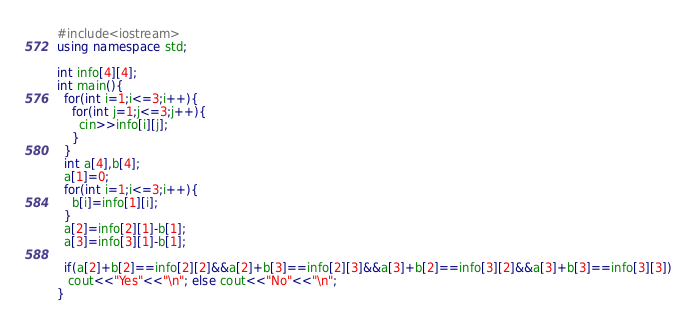<code> <loc_0><loc_0><loc_500><loc_500><_C++_>#include<iostream>
using namespace std;

int info[4][4];
int main(){
  for(int i=1;i<=3;i++){
    for(int j=1;j<=3;j++){
      cin>>info[i][j];
    }
  }
  int a[4],b[4];
  a[1]=0;
  for(int i=1;i<=3;i++){
    b[i]=info[1][i];
  }
  a[2]=info[2][1]-b[1];
  a[3]=info[3][1]-b[1];

  if(a[2]+b[2]==info[2][2]&&a[2]+b[3]==info[2][3]&&a[3]+b[2]==info[3][2]&&a[3]+b[3]==info[3][3])
   cout<<"Yes"<<"\n"; else cout<<"No"<<"\n";
}
</code> 